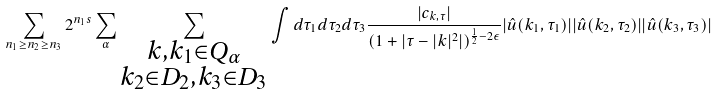Convert formula to latex. <formula><loc_0><loc_0><loc_500><loc_500>\sum _ { n _ { 1 } \geq n _ { 2 } \geq n _ { 3 } } 2 ^ { n _ { 1 } s } \sum _ { \alpha } \sum _ { \substack { k , k _ { 1 } \in Q _ { \alpha } \\ k _ { 2 } \in D _ { 2 } , k _ { 3 } \in D _ { 3 } } } \int d \tau _ { 1 } d \tau _ { 2 } d \tau _ { 3 } \frac { | c _ { k , \tau } | } { ( 1 + | \tau - | k | ^ { 2 } | ) ^ { \frac { 1 } { 2 } - 2 \epsilon } } | \hat { u } ( k _ { 1 } , \tau _ { 1 } ) | | \hat { u } ( k _ { 2 } , \tau _ { 2 } ) | | \hat { u } ( k _ { 3 } , \tau _ { 3 } ) |</formula> 